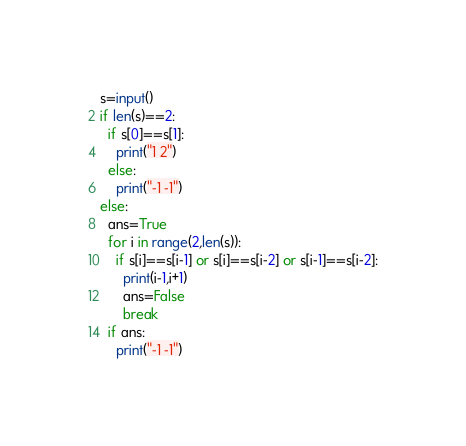Convert code to text. <code><loc_0><loc_0><loc_500><loc_500><_Python_>s=input()
if len(s)==2:
  if s[0]==s[1]:
    print("1 2")
  else:
    print("-1 -1")
else:
  ans=True
  for i in range(2,len(s)):
    if s[i]==s[i-1] or s[i]==s[i-2] or s[i-1]==s[i-2]:
      print(i-1,i+1)
      ans=False
      break
  if ans:
    print("-1 -1")</code> 